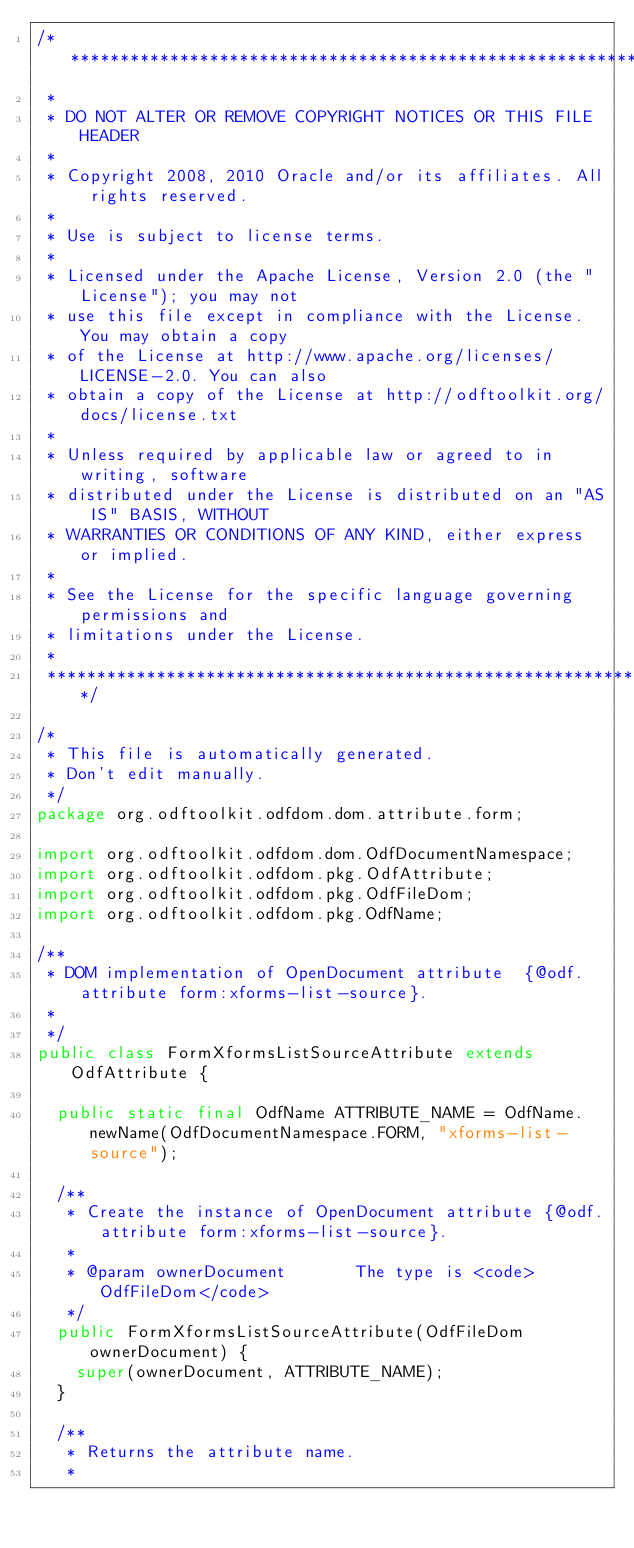<code> <loc_0><loc_0><loc_500><loc_500><_Java_>/************************************************************************
 *
 * DO NOT ALTER OR REMOVE COPYRIGHT NOTICES OR THIS FILE HEADER
 *
 * Copyright 2008, 2010 Oracle and/or its affiliates. All rights reserved.
 *
 * Use is subject to license terms.
 *
 * Licensed under the Apache License, Version 2.0 (the "License"); you may not
 * use this file except in compliance with the License. You may obtain a copy
 * of the License at http://www.apache.org/licenses/LICENSE-2.0. You can also
 * obtain a copy of the License at http://odftoolkit.org/docs/license.txt
 *
 * Unless required by applicable law or agreed to in writing, software
 * distributed under the License is distributed on an "AS IS" BASIS, WITHOUT
 * WARRANTIES OR CONDITIONS OF ANY KIND, either express or implied.
 *
 * See the License for the specific language governing permissions and
 * limitations under the License.
 *
 ************************************************************************/

/*
 * This file is automatically generated.
 * Don't edit manually.
 */
package org.odftoolkit.odfdom.dom.attribute.form;

import org.odftoolkit.odfdom.dom.OdfDocumentNamespace;
import org.odftoolkit.odfdom.pkg.OdfAttribute;
import org.odftoolkit.odfdom.pkg.OdfFileDom;
import org.odftoolkit.odfdom.pkg.OdfName;

/**
 * DOM implementation of OpenDocument attribute  {@odf.attribute form:xforms-list-source}.
 *
 */
public class FormXformsListSourceAttribute extends OdfAttribute {

	public static final OdfName ATTRIBUTE_NAME = OdfName.newName(OdfDocumentNamespace.FORM, "xforms-list-source");

	/**
	 * Create the instance of OpenDocument attribute {@odf.attribute form:xforms-list-source}.
	 *
	 * @param ownerDocument       The type is <code>OdfFileDom</code>
	 */
	public FormXformsListSourceAttribute(OdfFileDom ownerDocument) {
		super(ownerDocument, ATTRIBUTE_NAME);
	}

	/**
	 * Returns the attribute name.
	 *</code> 